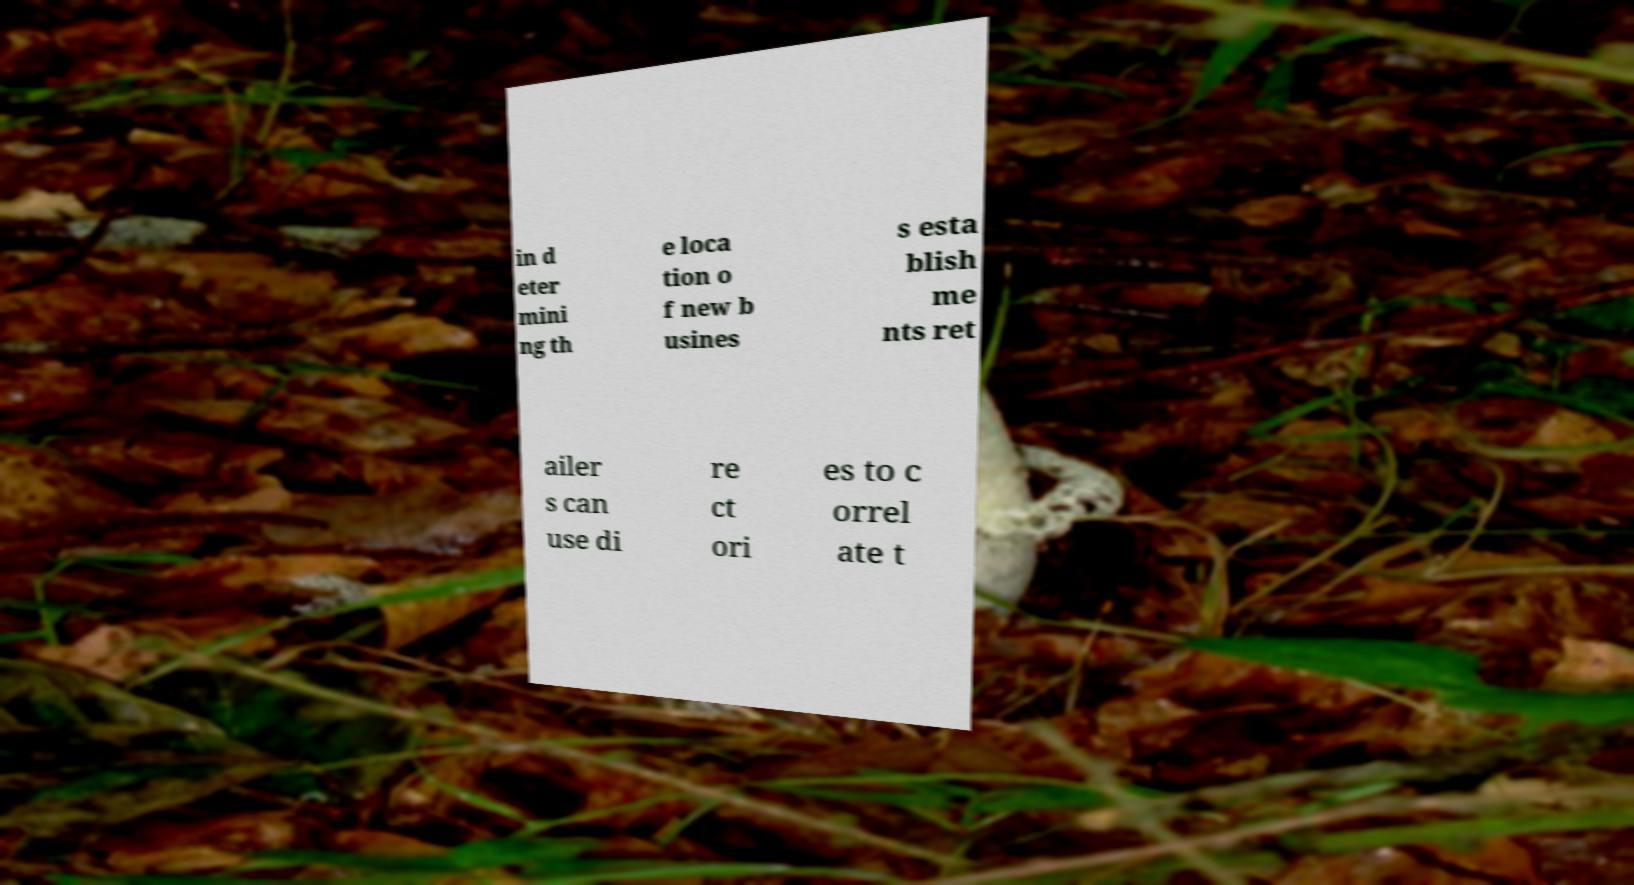Please identify and transcribe the text found in this image. in d eter mini ng th e loca tion o f new b usines s esta blish me nts ret ailer s can use di re ct ori es to c orrel ate t 